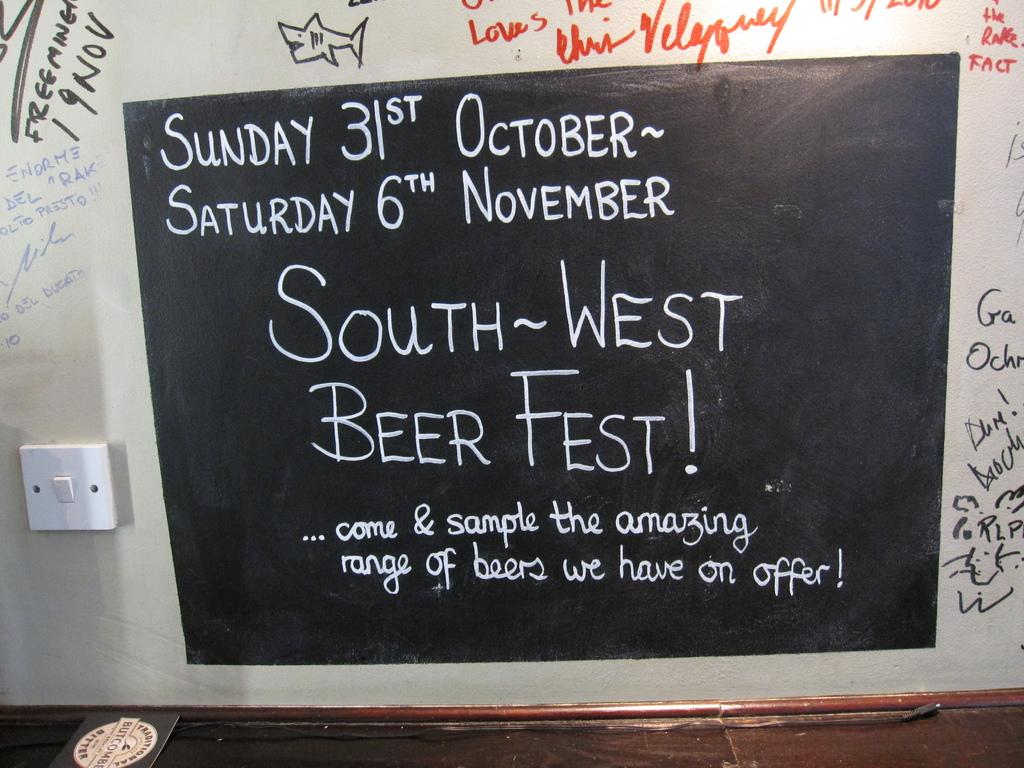<image>
Create a compact narrative representing the image presented. A blackboard displays an ad for the South-West Beer Fest! 